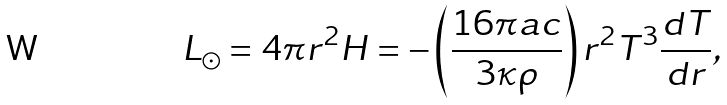<formula> <loc_0><loc_0><loc_500><loc_500>L _ { \odot } = 4 \pi r ^ { 2 } H = - \left ( \frac { 1 6 \pi a c } { 3 \kappa \rho } \right ) r ^ { 2 } T ^ { 3 } \frac { d T } { d r } ,</formula> 